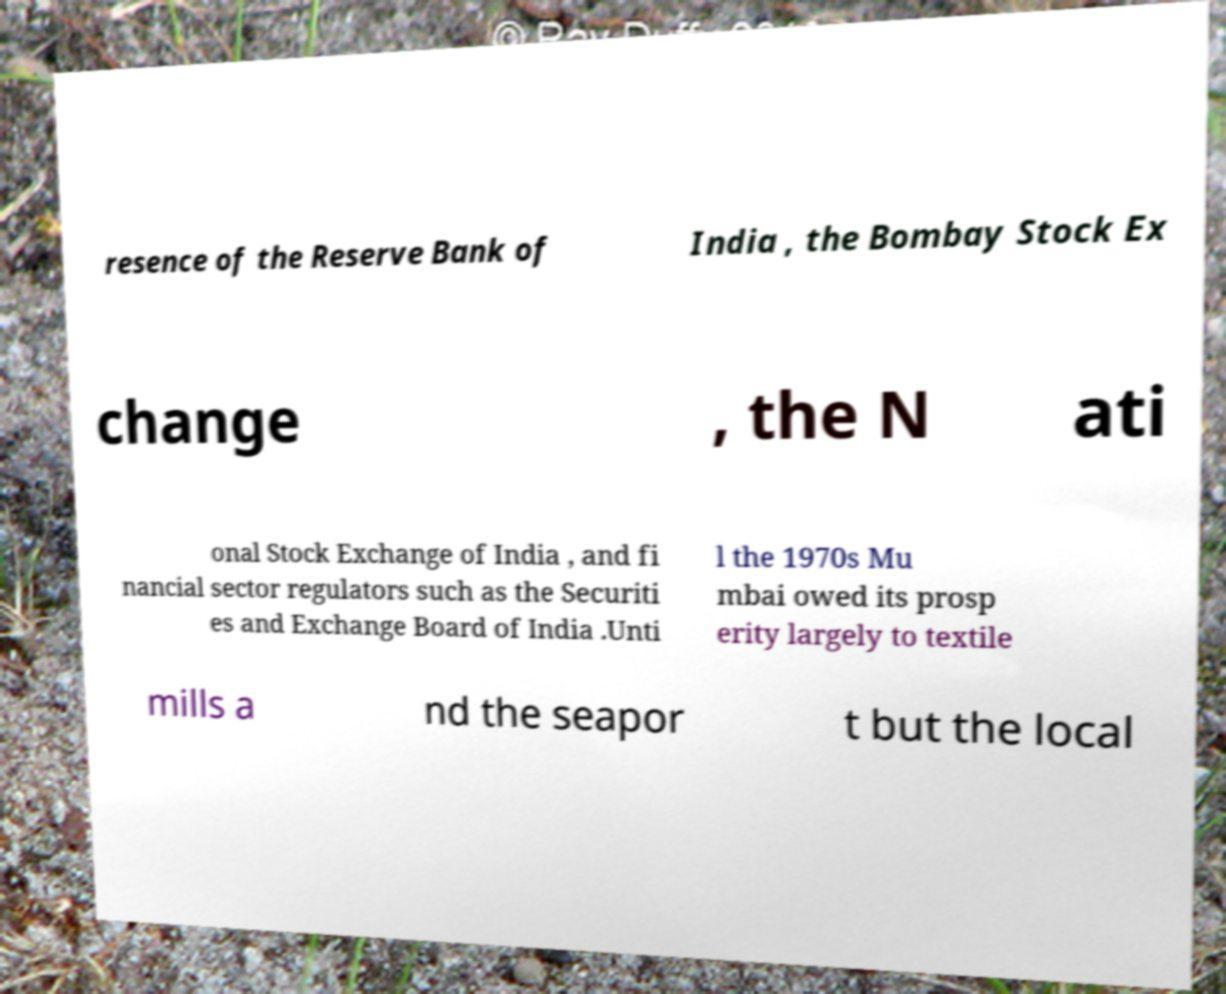Please identify and transcribe the text found in this image. resence of the Reserve Bank of India , the Bombay Stock Ex change , the N ati onal Stock Exchange of India , and fi nancial sector regulators such as the Securiti es and Exchange Board of India .Unti l the 1970s Mu mbai owed its prosp erity largely to textile mills a nd the seapor t but the local 